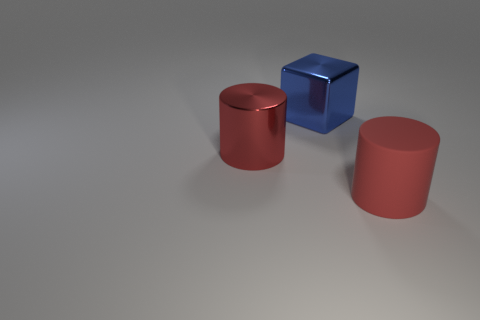What number of cylinders are behind the matte thing?
Give a very brief answer. 1. Are there fewer red matte things than large gray balls?
Make the answer very short. No. Do the large shiny object that is in front of the blue metallic cube and the matte cylinder have the same color?
Your answer should be compact. Yes. Is the number of cubes that are behind the big blue shiny cube less than the number of tiny cyan matte cylinders?
Provide a succinct answer. No. What shape is the red object that is the same material as the large block?
Keep it short and to the point. Cylinder. Is the number of big red metal things that are on the right side of the big red matte cylinder less than the number of large red cylinders that are to the left of the big blue shiny object?
Your answer should be very brief. Yes. What number of big red objects are right of the cylinder that is on the left side of the red cylinder that is on the right side of the blue metallic object?
Keep it short and to the point. 1. Do the matte cylinder and the large metal cylinder have the same color?
Your answer should be compact. Yes. Are there any shiny cylinders that have the same color as the matte object?
Provide a succinct answer. Yes. What is the color of the cube that is the same size as the matte object?
Ensure brevity in your answer.  Blue. 